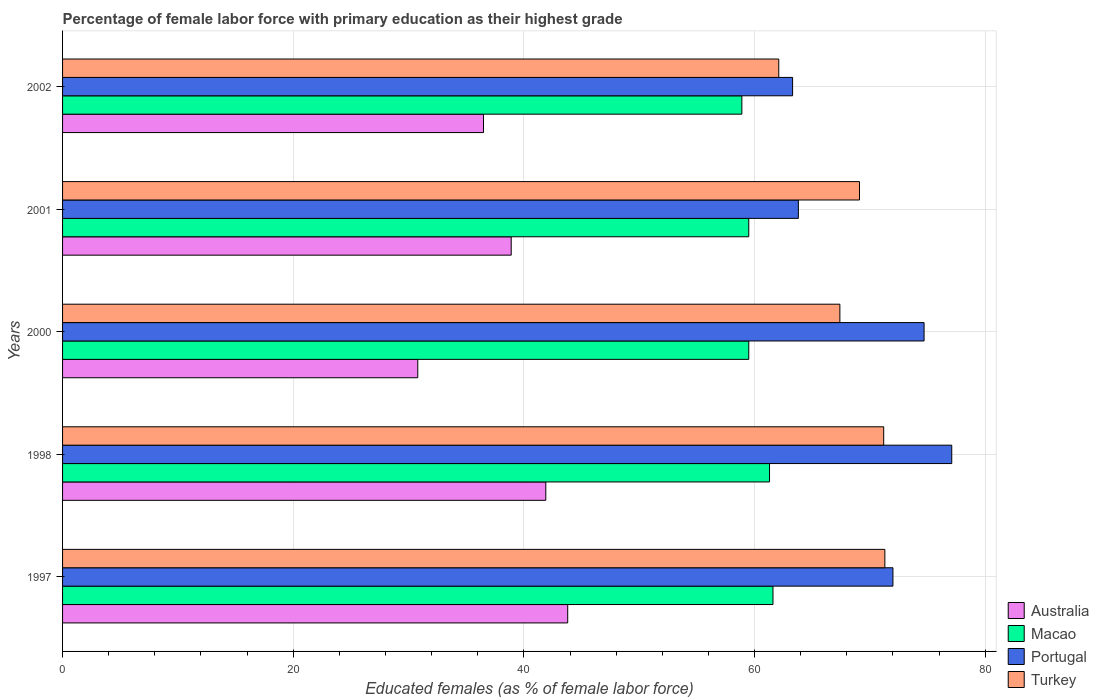How many groups of bars are there?
Keep it short and to the point. 5. Are the number of bars per tick equal to the number of legend labels?
Give a very brief answer. Yes. Are the number of bars on each tick of the Y-axis equal?
Make the answer very short. Yes. How many bars are there on the 4th tick from the top?
Keep it short and to the point. 4. What is the percentage of female labor force with primary education in Portugal in 2002?
Provide a short and direct response. 63.3. Across all years, what is the maximum percentage of female labor force with primary education in Turkey?
Your response must be concise. 71.3. Across all years, what is the minimum percentage of female labor force with primary education in Portugal?
Offer a terse response. 63.3. In which year was the percentage of female labor force with primary education in Australia maximum?
Make the answer very short. 1997. In which year was the percentage of female labor force with primary education in Turkey minimum?
Make the answer very short. 2002. What is the total percentage of female labor force with primary education in Turkey in the graph?
Offer a terse response. 341.1. What is the difference between the percentage of female labor force with primary education in Turkey in 2000 and that in 2001?
Offer a terse response. -1.7. What is the difference between the percentage of female labor force with primary education in Portugal in 2000 and the percentage of female labor force with primary education in Macao in 2002?
Your answer should be very brief. 15.8. What is the average percentage of female labor force with primary education in Turkey per year?
Provide a succinct answer. 68.22. In the year 2001, what is the difference between the percentage of female labor force with primary education in Macao and percentage of female labor force with primary education in Australia?
Keep it short and to the point. 20.6. What is the ratio of the percentage of female labor force with primary education in Turkey in 1997 to that in 1998?
Provide a short and direct response. 1. What is the difference between the highest and the second highest percentage of female labor force with primary education in Australia?
Provide a short and direct response. 1.9. What is the difference between the highest and the lowest percentage of female labor force with primary education in Portugal?
Provide a succinct answer. 13.8. Is the sum of the percentage of female labor force with primary education in Australia in 1997 and 1998 greater than the maximum percentage of female labor force with primary education in Macao across all years?
Offer a terse response. Yes. What does the 1st bar from the top in 2001 represents?
Provide a succinct answer. Turkey. What does the 1st bar from the bottom in 2001 represents?
Give a very brief answer. Australia. Is it the case that in every year, the sum of the percentage of female labor force with primary education in Portugal and percentage of female labor force with primary education in Macao is greater than the percentage of female labor force with primary education in Australia?
Make the answer very short. Yes. Are all the bars in the graph horizontal?
Your answer should be very brief. Yes. Does the graph contain any zero values?
Keep it short and to the point. No. How many legend labels are there?
Your response must be concise. 4. How are the legend labels stacked?
Provide a short and direct response. Vertical. What is the title of the graph?
Keep it short and to the point. Percentage of female labor force with primary education as their highest grade. What is the label or title of the X-axis?
Provide a succinct answer. Educated females (as % of female labor force). What is the Educated females (as % of female labor force) of Australia in 1997?
Ensure brevity in your answer.  43.8. What is the Educated females (as % of female labor force) of Macao in 1997?
Provide a succinct answer. 61.6. What is the Educated females (as % of female labor force) in Portugal in 1997?
Ensure brevity in your answer.  72. What is the Educated females (as % of female labor force) of Turkey in 1997?
Ensure brevity in your answer.  71.3. What is the Educated females (as % of female labor force) of Australia in 1998?
Give a very brief answer. 41.9. What is the Educated females (as % of female labor force) of Macao in 1998?
Provide a succinct answer. 61.3. What is the Educated females (as % of female labor force) of Portugal in 1998?
Provide a succinct answer. 77.1. What is the Educated females (as % of female labor force) in Turkey in 1998?
Make the answer very short. 71.2. What is the Educated females (as % of female labor force) of Australia in 2000?
Your answer should be compact. 30.8. What is the Educated females (as % of female labor force) in Macao in 2000?
Provide a succinct answer. 59.5. What is the Educated females (as % of female labor force) of Portugal in 2000?
Offer a terse response. 74.7. What is the Educated females (as % of female labor force) of Turkey in 2000?
Your answer should be very brief. 67.4. What is the Educated females (as % of female labor force) in Australia in 2001?
Provide a short and direct response. 38.9. What is the Educated females (as % of female labor force) in Macao in 2001?
Keep it short and to the point. 59.5. What is the Educated females (as % of female labor force) in Portugal in 2001?
Offer a very short reply. 63.8. What is the Educated females (as % of female labor force) in Turkey in 2001?
Your response must be concise. 69.1. What is the Educated females (as % of female labor force) of Australia in 2002?
Your response must be concise. 36.5. What is the Educated females (as % of female labor force) of Macao in 2002?
Ensure brevity in your answer.  58.9. What is the Educated females (as % of female labor force) in Portugal in 2002?
Ensure brevity in your answer.  63.3. What is the Educated females (as % of female labor force) of Turkey in 2002?
Make the answer very short. 62.1. Across all years, what is the maximum Educated females (as % of female labor force) in Australia?
Make the answer very short. 43.8. Across all years, what is the maximum Educated females (as % of female labor force) in Macao?
Give a very brief answer. 61.6. Across all years, what is the maximum Educated females (as % of female labor force) of Portugal?
Offer a very short reply. 77.1. Across all years, what is the maximum Educated females (as % of female labor force) of Turkey?
Keep it short and to the point. 71.3. Across all years, what is the minimum Educated females (as % of female labor force) in Australia?
Ensure brevity in your answer.  30.8. Across all years, what is the minimum Educated females (as % of female labor force) of Macao?
Your answer should be compact. 58.9. Across all years, what is the minimum Educated females (as % of female labor force) in Portugal?
Your answer should be very brief. 63.3. Across all years, what is the minimum Educated females (as % of female labor force) of Turkey?
Give a very brief answer. 62.1. What is the total Educated females (as % of female labor force) of Australia in the graph?
Provide a succinct answer. 191.9. What is the total Educated females (as % of female labor force) of Macao in the graph?
Offer a very short reply. 300.8. What is the total Educated females (as % of female labor force) of Portugal in the graph?
Your response must be concise. 350.9. What is the total Educated females (as % of female labor force) of Turkey in the graph?
Give a very brief answer. 341.1. What is the difference between the Educated females (as % of female labor force) in Australia in 1997 and that in 1998?
Keep it short and to the point. 1.9. What is the difference between the Educated females (as % of female labor force) of Macao in 1997 and that in 1998?
Make the answer very short. 0.3. What is the difference between the Educated females (as % of female labor force) in Portugal in 1997 and that in 1998?
Give a very brief answer. -5.1. What is the difference between the Educated females (as % of female labor force) of Turkey in 1997 and that in 1998?
Keep it short and to the point. 0.1. What is the difference between the Educated females (as % of female labor force) in Portugal in 1997 and that in 2000?
Your answer should be compact. -2.7. What is the difference between the Educated females (as % of female labor force) in Turkey in 1997 and that in 2000?
Your answer should be compact. 3.9. What is the difference between the Educated females (as % of female labor force) in Australia in 1997 and that in 2001?
Provide a short and direct response. 4.9. What is the difference between the Educated females (as % of female labor force) of Macao in 1997 and that in 2002?
Keep it short and to the point. 2.7. What is the difference between the Educated females (as % of female labor force) in Macao in 1998 and that in 2000?
Provide a short and direct response. 1.8. What is the difference between the Educated females (as % of female labor force) in Turkey in 1998 and that in 2000?
Provide a succinct answer. 3.8. What is the difference between the Educated females (as % of female labor force) in Australia in 1998 and that in 2001?
Ensure brevity in your answer.  3. What is the difference between the Educated females (as % of female labor force) of Turkey in 1998 and that in 2001?
Offer a very short reply. 2.1. What is the difference between the Educated females (as % of female labor force) in Australia in 1998 and that in 2002?
Offer a terse response. 5.4. What is the difference between the Educated females (as % of female labor force) of Australia in 2000 and that in 2001?
Your response must be concise. -8.1. What is the difference between the Educated females (as % of female labor force) of Portugal in 2000 and that in 2001?
Offer a very short reply. 10.9. What is the difference between the Educated females (as % of female labor force) of Australia in 2000 and that in 2002?
Give a very brief answer. -5.7. What is the difference between the Educated females (as % of female labor force) of Turkey in 2000 and that in 2002?
Keep it short and to the point. 5.3. What is the difference between the Educated females (as % of female labor force) of Australia in 2001 and that in 2002?
Ensure brevity in your answer.  2.4. What is the difference between the Educated females (as % of female labor force) in Macao in 2001 and that in 2002?
Your answer should be compact. 0.6. What is the difference between the Educated females (as % of female labor force) of Australia in 1997 and the Educated females (as % of female labor force) of Macao in 1998?
Your answer should be compact. -17.5. What is the difference between the Educated females (as % of female labor force) in Australia in 1997 and the Educated females (as % of female labor force) in Portugal in 1998?
Provide a succinct answer. -33.3. What is the difference between the Educated females (as % of female labor force) of Australia in 1997 and the Educated females (as % of female labor force) of Turkey in 1998?
Keep it short and to the point. -27.4. What is the difference between the Educated females (as % of female labor force) of Macao in 1997 and the Educated females (as % of female labor force) of Portugal in 1998?
Your answer should be very brief. -15.5. What is the difference between the Educated females (as % of female labor force) in Portugal in 1997 and the Educated females (as % of female labor force) in Turkey in 1998?
Make the answer very short. 0.8. What is the difference between the Educated females (as % of female labor force) of Australia in 1997 and the Educated females (as % of female labor force) of Macao in 2000?
Your response must be concise. -15.7. What is the difference between the Educated females (as % of female labor force) in Australia in 1997 and the Educated females (as % of female labor force) in Portugal in 2000?
Keep it short and to the point. -30.9. What is the difference between the Educated females (as % of female labor force) of Australia in 1997 and the Educated females (as % of female labor force) of Turkey in 2000?
Ensure brevity in your answer.  -23.6. What is the difference between the Educated females (as % of female labor force) in Macao in 1997 and the Educated females (as % of female labor force) in Portugal in 2000?
Offer a terse response. -13.1. What is the difference between the Educated females (as % of female labor force) of Macao in 1997 and the Educated females (as % of female labor force) of Turkey in 2000?
Provide a short and direct response. -5.8. What is the difference between the Educated females (as % of female labor force) of Australia in 1997 and the Educated females (as % of female labor force) of Macao in 2001?
Keep it short and to the point. -15.7. What is the difference between the Educated females (as % of female labor force) of Australia in 1997 and the Educated females (as % of female labor force) of Portugal in 2001?
Give a very brief answer. -20. What is the difference between the Educated females (as % of female labor force) of Australia in 1997 and the Educated females (as % of female labor force) of Turkey in 2001?
Keep it short and to the point. -25.3. What is the difference between the Educated females (as % of female labor force) of Macao in 1997 and the Educated females (as % of female labor force) of Portugal in 2001?
Keep it short and to the point. -2.2. What is the difference between the Educated females (as % of female labor force) in Portugal in 1997 and the Educated females (as % of female labor force) in Turkey in 2001?
Keep it short and to the point. 2.9. What is the difference between the Educated females (as % of female labor force) of Australia in 1997 and the Educated females (as % of female labor force) of Macao in 2002?
Make the answer very short. -15.1. What is the difference between the Educated females (as % of female labor force) in Australia in 1997 and the Educated females (as % of female labor force) in Portugal in 2002?
Your response must be concise. -19.5. What is the difference between the Educated females (as % of female labor force) in Australia in 1997 and the Educated females (as % of female labor force) in Turkey in 2002?
Provide a succinct answer. -18.3. What is the difference between the Educated females (as % of female labor force) of Macao in 1997 and the Educated females (as % of female labor force) of Turkey in 2002?
Your answer should be compact. -0.5. What is the difference between the Educated females (as % of female labor force) in Australia in 1998 and the Educated females (as % of female labor force) in Macao in 2000?
Provide a succinct answer. -17.6. What is the difference between the Educated females (as % of female labor force) in Australia in 1998 and the Educated females (as % of female labor force) in Portugal in 2000?
Provide a succinct answer. -32.8. What is the difference between the Educated females (as % of female labor force) of Australia in 1998 and the Educated females (as % of female labor force) of Turkey in 2000?
Ensure brevity in your answer.  -25.5. What is the difference between the Educated females (as % of female labor force) of Macao in 1998 and the Educated females (as % of female labor force) of Turkey in 2000?
Provide a short and direct response. -6.1. What is the difference between the Educated females (as % of female labor force) of Australia in 1998 and the Educated females (as % of female labor force) of Macao in 2001?
Provide a succinct answer. -17.6. What is the difference between the Educated females (as % of female labor force) of Australia in 1998 and the Educated females (as % of female labor force) of Portugal in 2001?
Your answer should be compact. -21.9. What is the difference between the Educated females (as % of female labor force) in Australia in 1998 and the Educated females (as % of female labor force) in Turkey in 2001?
Keep it short and to the point. -27.2. What is the difference between the Educated females (as % of female labor force) of Macao in 1998 and the Educated females (as % of female labor force) of Portugal in 2001?
Ensure brevity in your answer.  -2.5. What is the difference between the Educated females (as % of female labor force) of Portugal in 1998 and the Educated females (as % of female labor force) of Turkey in 2001?
Your answer should be very brief. 8. What is the difference between the Educated females (as % of female labor force) of Australia in 1998 and the Educated females (as % of female labor force) of Macao in 2002?
Keep it short and to the point. -17. What is the difference between the Educated females (as % of female labor force) of Australia in 1998 and the Educated females (as % of female labor force) of Portugal in 2002?
Offer a very short reply. -21.4. What is the difference between the Educated females (as % of female labor force) in Australia in 1998 and the Educated females (as % of female labor force) in Turkey in 2002?
Offer a terse response. -20.2. What is the difference between the Educated females (as % of female labor force) of Macao in 1998 and the Educated females (as % of female labor force) of Portugal in 2002?
Offer a terse response. -2. What is the difference between the Educated females (as % of female labor force) in Macao in 1998 and the Educated females (as % of female labor force) in Turkey in 2002?
Ensure brevity in your answer.  -0.8. What is the difference between the Educated females (as % of female labor force) in Australia in 2000 and the Educated females (as % of female labor force) in Macao in 2001?
Offer a terse response. -28.7. What is the difference between the Educated females (as % of female labor force) in Australia in 2000 and the Educated females (as % of female labor force) in Portugal in 2001?
Make the answer very short. -33. What is the difference between the Educated females (as % of female labor force) of Australia in 2000 and the Educated females (as % of female labor force) of Turkey in 2001?
Your answer should be compact. -38.3. What is the difference between the Educated females (as % of female labor force) of Macao in 2000 and the Educated females (as % of female labor force) of Portugal in 2001?
Give a very brief answer. -4.3. What is the difference between the Educated females (as % of female labor force) in Australia in 2000 and the Educated females (as % of female labor force) in Macao in 2002?
Make the answer very short. -28.1. What is the difference between the Educated females (as % of female labor force) of Australia in 2000 and the Educated females (as % of female labor force) of Portugal in 2002?
Offer a very short reply. -32.5. What is the difference between the Educated females (as % of female labor force) in Australia in 2000 and the Educated females (as % of female labor force) in Turkey in 2002?
Offer a very short reply. -31.3. What is the difference between the Educated females (as % of female labor force) of Macao in 2000 and the Educated females (as % of female labor force) of Portugal in 2002?
Offer a very short reply. -3.8. What is the difference between the Educated females (as % of female labor force) in Macao in 2000 and the Educated females (as % of female labor force) in Turkey in 2002?
Your answer should be very brief. -2.6. What is the difference between the Educated females (as % of female labor force) in Portugal in 2000 and the Educated females (as % of female labor force) in Turkey in 2002?
Keep it short and to the point. 12.6. What is the difference between the Educated females (as % of female labor force) in Australia in 2001 and the Educated females (as % of female labor force) in Portugal in 2002?
Ensure brevity in your answer.  -24.4. What is the difference between the Educated females (as % of female labor force) in Australia in 2001 and the Educated females (as % of female labor force) in Turkey in 2002?
Provide a short and direct response. -23.2. What is the difference between the Educated females (as % of female labor force) in Macao in 2001 and the Educated females (as % of female labor force) in Portugal in 2002?
Give a very brief answer. -3.8. What is the difference between the Educated females (as % of female labor force) of Macao in 2001 and the Educated females (as % of female labor force) of Turkey in 2002?
Give a very brief answer. -2.6. What is the difference between the Educated females (as % of female labor force) of Portugal in 2001 and the Educated females (as % of female labor force) of Turkey in 2002?
Your answer should be very brief. 1.7. What is the average Educated females (as % of female labor force) in Australia per year?
Ensure brevity in your answer.  38.38. What is the average Educated females (as % of female labor force) of Macao per year?
Give a very brief answer. 60.16. What is the average Educated females (as % of female labor force) in Portugal per year?
Provide a succinct answer. 70.18. What is the average Educated females (as % of female labor force) of Turkey per year?
Your response must be concise. 68.22. In the year 1997, what is the difference between the Educated females (as % of female labor force) of Australia and Educated females (as % of female labor force) of Macao?
Provide a short and direct response. -17.8. In the year 1997, what is the difference between the Educated females (as % of female labor force) in Australia and Educated females (as % of female labor force) in Portugal?
Your response must be concise. -28.2. In the year 1997, what is the difference between the Educated females (as % of female labor force) in Australia and Educated females (as % of female labor force) in Turkey?
Offer a terse response. -27.5. In the year 1997, what is the difference between the Educated females (as % of female labor force) in Macao and Educated females (as % of female labor force) in Portugal?
Ensure brevity in your answer.  -10.4. In the year 1997, what is the difference between the Educated females (as % of female labor force) in Portugal and Educated females (as % of female labor force) in Turkey?
Provide a succinct answer. 0.7. In the year 1998, what is the difference between the Educated females (as % of female labor force) in Australia and Educated females (as % of female labor force) in Macao?
Give a very brief answer. -19.4. In the year 1998, what is the difference between the Educated females (as % of female labor force) in Australia and Educated females (as % of female labor force) in Portugal?
Provide a succinct answer. -35.2. In the year 1998, what is the difference between the Educated females (as % of female labor force) of Australia and Educated females (as % of female labor force) of Turkey?
Offer a terse response. -29.3. In the year 1998, what is the difference between the Educated females (as % of female labor force) in Macao and Educated females (as % of female labor force) in Portugal?
Ensure brevity in your answer.  -15.8. In the year 1998, what is the difference between the Educated females (as % of female labor force) of Macao and Educated females (as % of female labor force) of Turkey?
Keep it short and to the point. -9.9. In the year 2000, what is the difference between the Educated females (as % of female labor force) in Australia and Educated females (as % of female labor force) in Macao?
Your answer should be very brief. -28.7. In the year 2000, what is the difference between the Educated females (as % of female labor force) of Australia and Educated females (as % of female labor force) of Portugal?
Provide a succinct answer. -43.9. In the year 2000, what is the difference between the Educated females (as % of female labor force) in Australia and Educated females (as % of female labor force) in Turkey?
Provide a succinct answer. -36.6. In the year 2000, what is the difference between the Educated females (as % of female labor force) of Macao and Educated females (as % of female labor force) of Portugal?
Your answer should be compact. -15.2. In the year 2000, what is the difference between the Educated females (as % of female labor force) in Macao and Educated females (as % of female labor force) in Turkey?
Give a very brief answer. -7.9. In the year 2001, what is the difference between the Educated females (as % of female labor force) of Australia and Educated females (as % of female labor force) of Macao?
Your answer should be compact. -20.6. In the year 2001, what is the difference between the Educated females (as % of female labor force) in Australia and Educated females (as % of female labor force) in Portugal?
Make the answer very short. -24.9. In the year 2001, what is the difference between the Educated females (as % of female labor force) of Australia and Educated females (as % of female labor force) of Turkey?
Provide a short and direct response. -30.2. In the year 2001, what is the difference between the Educated females (as % of female labor force) of Portugal and Educated females (as % of female labor force) of Turkey?
Offer a terse response. -5.3. In the year 2002, what is the difference between the Educated females (as % of female labor force) in Australia and Educated females (as % of female labor force) in Macao?
Provide a short and direct response. -22.4. In the year 2002, what is the difference between the Educated females (as % of female labor force) in Australia and Educated females (as % of female labor force) in Portugal?
Offer a very short reply. -26.8. In the year 2002, what is the difference between the Educated females (as % of female labor force) of Australia and Educated females (as % of female labor force) of Turkey?
Your answer should be very brief. -25.6. In the year 2002, what is the difference between the Educated females (as % of female labor force) in Macao and Educated females (as % of female labor force) in Portugal?
Make the answer very short. -4.4. In the year 2002, what is the difference between the Educated females (as % of female labor force) of Macao and Educated females (as % of female labor force) of Turkey?
Your answer should be compact. -3.2. What is the ratio of the Educated females (as % of female labor force) of Australia in 1997 to that in 1998?
Keep it short and to the point. 1.05. What is the ratio of the Educated females (as % of female labor force) in Macao in 1997 to that in 1998?
Your answer should be very brief. 1. What is the ratio of the Educated females (as % of female labor force) in Portugal in 1997 to that in 1998?
Keep it short and to the point. 0.93. What is the ratio of the Educated females (as % of female labor force) of Australia in 1997 to that in 2000?
Provide a succinct answer. 1.42. What is the ratio of the Educated females (as % of female labor force) of Macao in 1997 to that in 2000?
Give a very brief answer. 1.04. What is the ratio of the Educated females (as % of female labor force) of Portugal in 1997 to that in 2000?
Your answer should be compact. 0.96. What is the ratio of the Educated females (as % of female labor force) in Turkey in 1997 to that in 2000?
Offer a very short reply. 1.06. What is the ratio of the Educated females (as % of female labor force) in Australia in 1997 to that in 2001?
Offer a terse response. 1.13. What is the ratio of the Educated females (as % of female labor force) of Macao in 1997 to that in 2001?
Your response must be concise. 1.04. What is the ratio of the Educated females (as % of female labor force) of Portugal in 1997 to that in 2001?
Give a very brief answer. 1.13. What is the ratio of the Educated females (as % of female labor force) in Turkey in 1997 to that in 2001?
Ensure brevity in your answer.  1.03. What is the ratio of the Educated females (as % of female labor force) of Australia in 1997 to that in 2002?
Your response must be concise. 1.2. What is the ratio of the Educated females (as % of female labor force) in Macao in 1997 to that in 2002?
Your answer should be very brief. 1.05. What is the ratio of the Educated females (as % of female labor force) of Portugal in 1997 to that in 2002?
Offer a very short reply. 1.14. What is the ratio of the Educated females (as % of female labor force) in Turkey in 1997 to that in 2002?
Keep it short and to the point. 1.15. What is the ratio of the Educated females (as % of female labor force) in Australia in 1998 to that in 2000?
Make the answer very short. 1.36. What is the ratio of the Educated females (as % of female labor force) in Macao in 1998 to that in 2000?
Your answer should be very brief. 1.03. What is the ratio of the Educated females (as % of female labor force) of Portugal in 1998 to that in 2000?
Offer a terse response. 1.03. What is the ratio of the Educated females (as % of female labor force) in Turkey in 1998 to that in 2000?
Your answer should be compact. 1.06. What is the ratio of the Educated females (as % of female labor force) of Australia in 1998 to that in 2001?
Ensure brevity in your answer.  1.08. What is the ratio of the Educated females (as % of female labor force) of Macao in 1998 to that in 2001?
Keep it short and to the point. 1.03. What is the ratio of the Educated females (as % of female labor force) in Portugal in 1998 to that in 2001?
Ensure brevity in your answer.  1.21. What is the ratio of the Educated females (as % of female labor force) in Turkey in 1998 to that in 2001?
Your answer should be compact. 1.03. What is the ratio of the Educated females (as % of female labor force) of Australia in 1998 to that in 2002?
Provide a short and direct response. 1.15. What is the ratio of the Educated females (as % of female labor force) of Macao in 1998 to that in 2002?
Provide a succinct answer. 1.04. What is the ratio of the Educated females (as % of female labor force) in Portugal in 1998 to that in 2002?
Make the answer very short. 1.22. What is the ratio of the Educated females (as % of female labor force) of Turkey in 1998 to that in 2002?
Your response must be concise. 1.15. What is the ratio of the Educated females (as % of female labor force) of Australia in 2000 to that in 2001?
Provide a short and direct response. 0.79. What is the ratio of the Educated females (as % of female labor force) in Portugal in 2000 to that in 2001?
Ensure brevity in your answer.  1.17. What is the ratio of the Educated females (as % of female labor force) of Turkey in 2000 to that in 2001?
Make the answer very short. 0.98. What is the ratio of the Educated females (as % of female labor force) in Australia in 2000 to that in 2002?
Make the answer very short. 0.84. What is the ratio of the Educated females (as % of female labor force) of Macao in 2000 to that in 2002?
Ensure brevity in your answer.  1.01. What is the ratio of the Educated females (as % of female labor force) of Portugal in 2000 to that in 2002?
Make the answer very short. 1.18. What is the ratio of the Educated females (as % of female labor force) of Turkey in 2000 to that in 2002?
Make the answer very short. 1.09. What is the ratio of the Educated females (as % of female labor force) of Australia in 2001 to that in 2002?
Keep it short and to the point. 1.07. What is the ratio of the Educated females (as % of female labor force) in Macao in 2001 to that in 2002?
Your answer should be compact. 1.01. What is the ratio of the Educated females (as % of female labor force) in Portugal in 2001 to that in 2002?
Make the answer very short. 1.01. What is the ratio of the Educated females (as % of female labor force) in Turkey in 2001 to that in 2002?
Offer a terse response. 1.11. What is the difference between the highest and the second highest Educated females (as % of female labor force) in Australia?
Ensure brevity in your answer.  1.9. What is the difference between the highest and the second highest Educated females (as % of female labor force) in Turkey?
Provide a short and direct response. 0.1. What is the difference between the highest and the lowest Educated females (as % of female labor force) in Portugal?
Give a very brief answer. 13.8. 